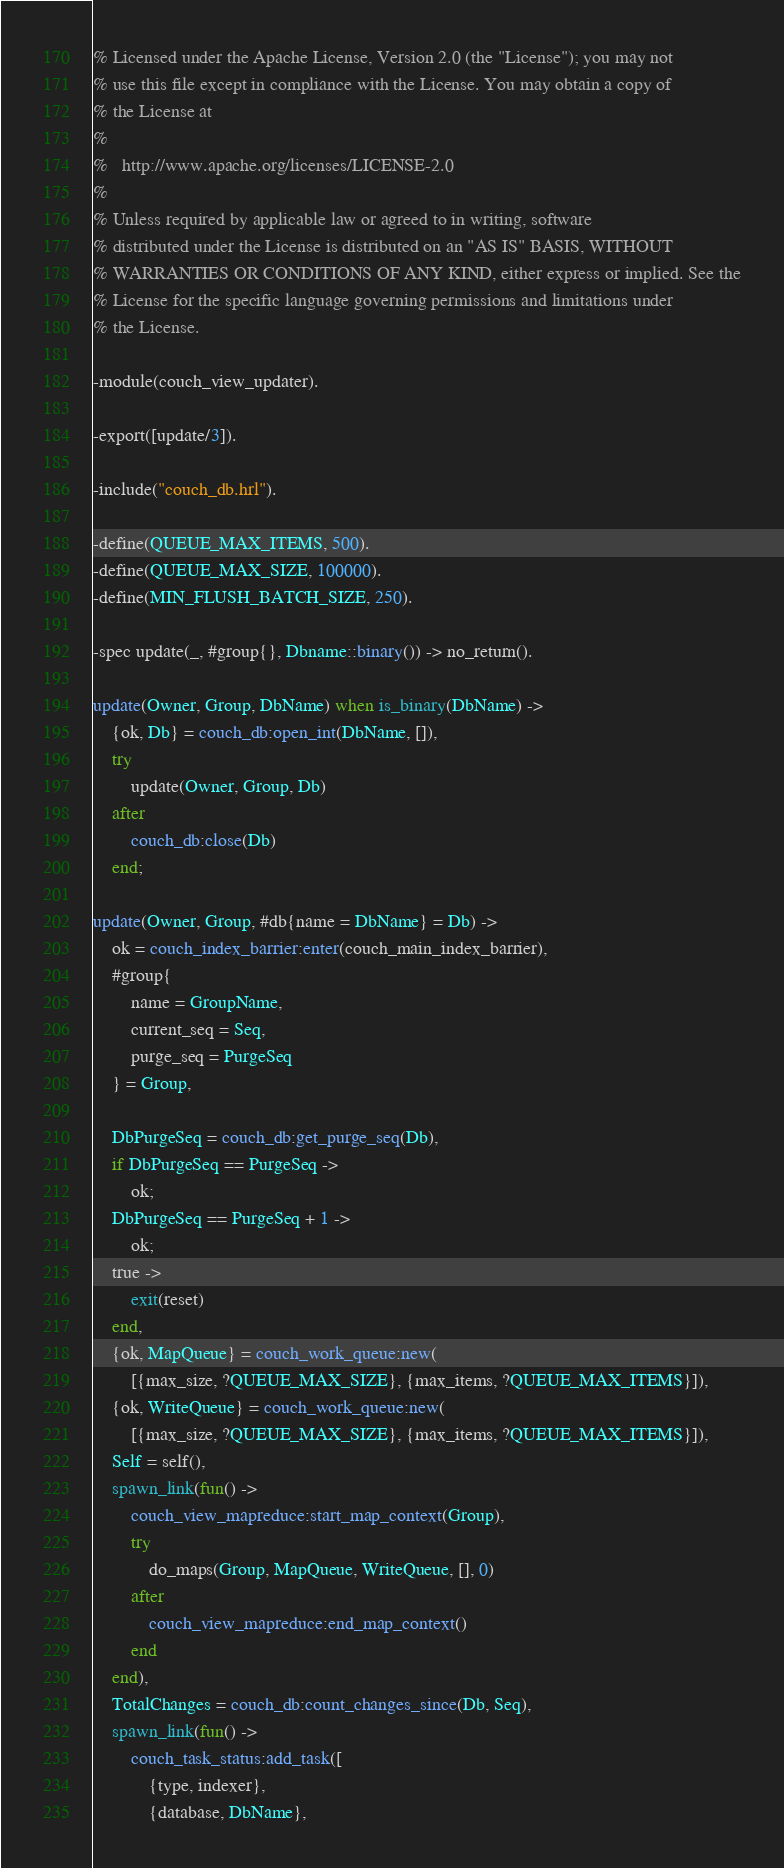<code> <loc_0><loc_0><loc_500><loc_500><_Erlang_>% Licensed under the Apache License, Version 2.0 (the "License"); you may not
% use this file except in compliance with the License. You may obtain a copy of
% the License at
%
%   http://www.apache.org/licenses/LICENSE-2.0
%
% Unless required by applicable law or agreed to in writing, software
% distributed under the License is distributed on an "AS IS" BASIS, WITHOUT
% WARRANTIES OR CONDITIONS OF ANY KIND, either express or implied. See the
% License for the specific language governing permissions and limitations under
% the License.

-module(couch_view_updater).

-export([update/3]).

-include("couch_db.hrl").

-define(QUEUE_MAX_ITEMS, 500).
-define(QUEUE_MAX_SIZE, 100000).
-define(MIN_FLUSH_BATCH_SIZE, 250).

-spec update(_, #group{}, Dbname::binary()) -> no_return().

update(Owner, Group, DbName) when is_binary(DbName) ->
    {ok, Db} = couch_db:open_int(DbName, []),
    try
        update(Owner, Group, Db)
    after
        couch_db:close(Db)
    end;

update(Owner, Group, #db{name = DbName} = Db) ->
    ok = couch_index_barrier:enter(couch_main_index_barrier),
    #group{
        name = GroupName,
        current_seq = Seq,
        purge_seq = PurgeSeq
    } = Group,

    DbPurgeSeq = couch_db:get_purge_seq(Db),
    if DbPurgeSeq == PurgeSeq ->
        ok;
    DbPurgeSeq == PurgeSeq + 1 ->
        ok;
    true ->
        exit(reset)
    end,
    {ok, MapQueue} = couch_work_queue:new(
        [{max_size, ?QUEUE_MAX_SIZE}, {max_items, ?QUEUE_MAX_ITEMS}]),
    {ok, WriteQueue} = couch_work_queue:new(
        [{max_size, ?QUEUE_MAX_SIZE}, {max_items, ?QUEUE_MAX_ITEMS}]),
    Self = self(),
    spawn_link(fun() ->
        couch_view_mapreduce:start_map_context(Group),
        try
            do_maps(Group, MapQueue, WriteQueue, [], 0)
        after
            couch_view_mapreduce:end_map_context()
        end
    end),
    TotalChanges = couch_db:count_changes_since(Db, Seq),
    spawn_link(fun() ->
        couch_task_status:add_task([
            {type, indexer},
            {database, DbName},</code> 